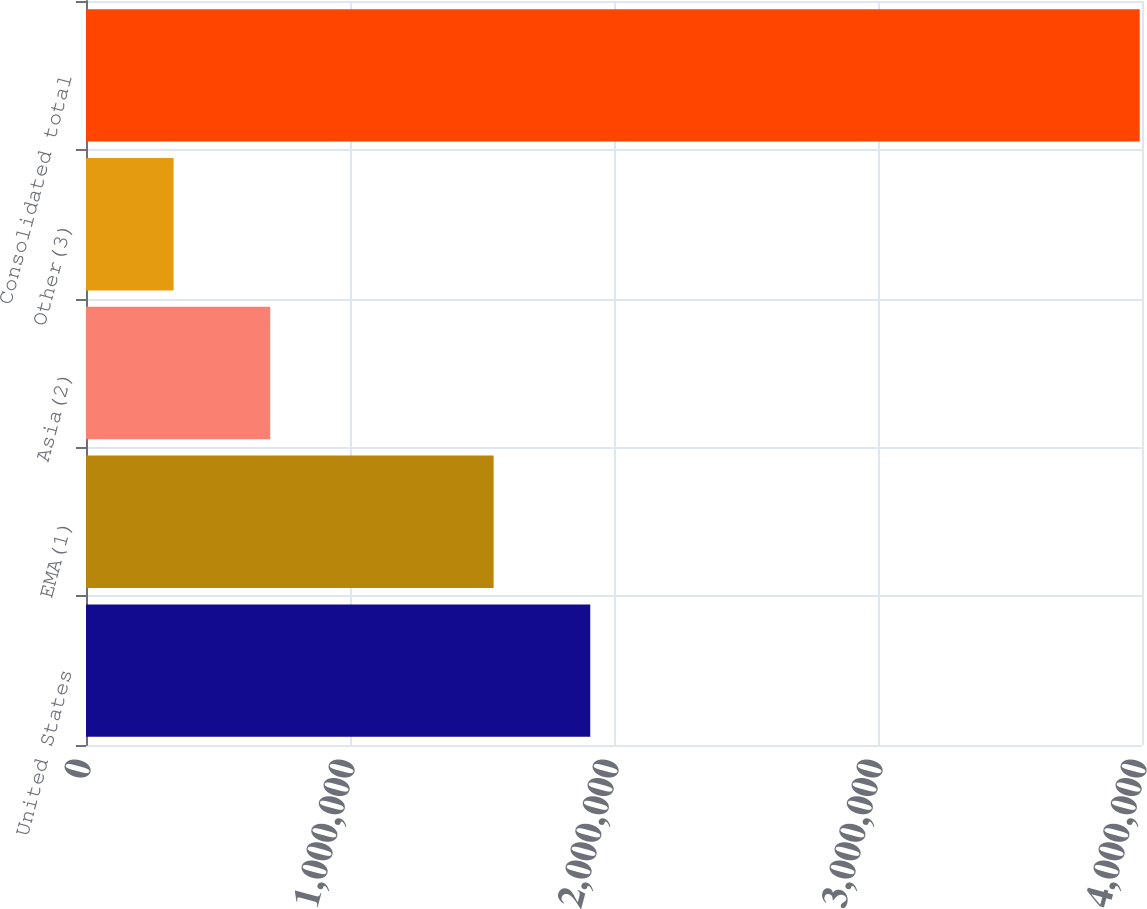<chart> <loc_0><loc_0><loc_500><loc_500><bar_chart><fcel>United States<fcel>EMA(1)<fcel>Asia(2)<fcel>Other(3)<fcel>Consolidated total<nl><fcel>1.91006e+06<fcel>1.5441e+06<fcel>697811<fcel>331850<fcel>3.99146e+06<nl></chart> 